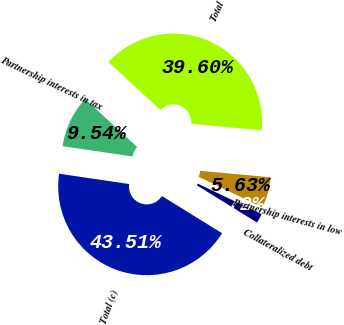<chart> <loc_0><loc_0><loc_500><loc_500><pie_chart><fcel>Partnership interests in tax<fcel>Total (c)<fcel>Collateralized debt<fcel>Partnership interests in low<fcel>Total<nl><fcel>9.54%<fcel>43.51%<fcel>1.72%<fcel>5.63%<fcel>39.6%<nl></chart> 